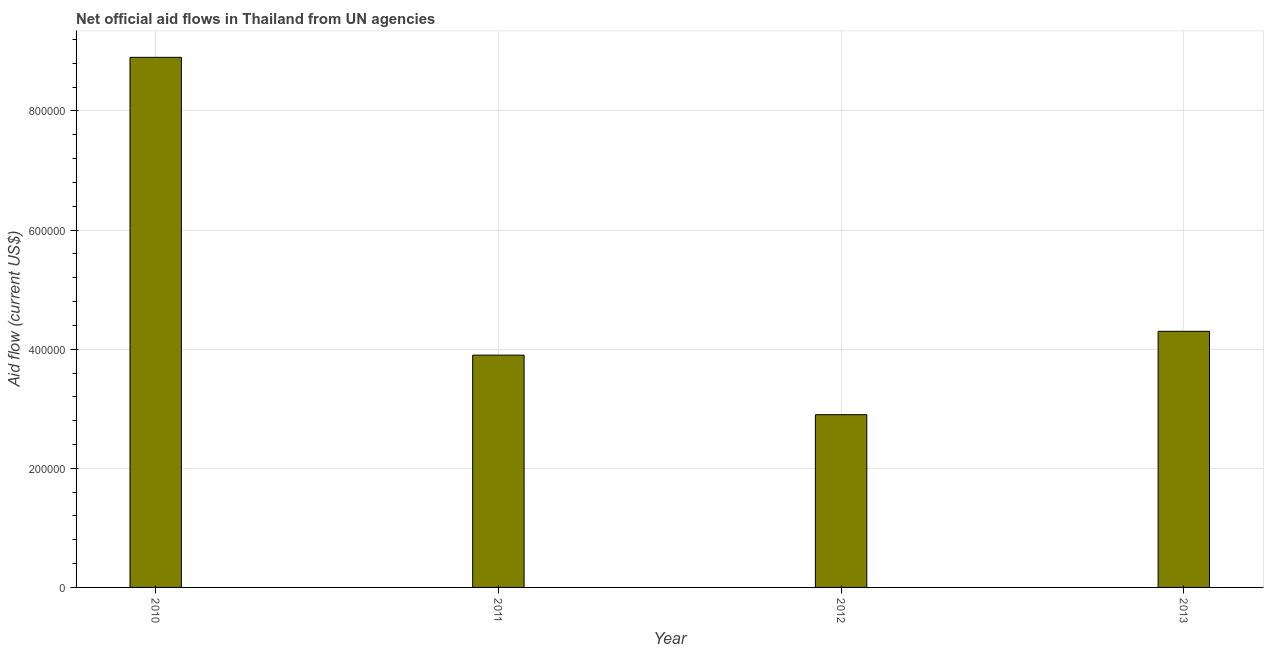Does the graph contain grids?
Make the answer very short. Yes. What is the title of the graph?
Give a very brief answer. Net official aid flows in Thailand from UN agencies. What is the label or title of the X-axis?
Your response must be concise. Year. What is the net official flows from un agencies in 2011?
Offer a very short reply. 3.90e+05. Across all years, what is the maximum net official flows from un agencies?
Provide a short and direct response. 8.90e+05. In how many years, is the net official flows from un agencies greater than 640000 US$?
Give a very brief answer. 1. Do a majority of the years between 2011 and 2010 (inclusive) have net official flows from un agencies greater than 80000 US$?
Offer a terse response. No. What is the ratio of the net official flows from un agencies in 2011 to that in 2012?
Your response must be concise. 1.34. Is the difference between the net official flows from un agencies in 2010 and 2012 greater than the difference between any two years?
Give a very brief answer. Yes. Is the sum of the net official flows from un agencies in 2010 and 2011 greater than the maximum net official flows from un agencies across all years?
Make the answer very short. Yes. How many bars are there?
Provide a short and direct response. 4. How many years are there in the graph?
Provide a succinct answer. 4. What is the difference between two consecutive major ticks on the Y-axis?
Your answer should be compact. 2.00e+05. What is the Aid flow (current US$) of 2010?
Provide a short and direct response. 8.90e+05. What is the Aid flow (current US$) in 2011?
Offer a terse response. 3.90e+05. What is the Aid flow (current US$) in 2012?
Provide a short and direct response. 2.90e+05. What is the difference between the Aid flow (current US$) in 2010 and 2011?
Your answer should be very brief. 5.00e+05. What is the difference between the Aid flow (current US$) in 2010 and 2013?
Make the answer very short. 4.60e+05. What is the difference between the Aid flow (current US$) in 2011 and 2013?
Offer a very short reply. -4.00e+04. What is the ratio of the Aid flow (current US$) in 2010 to that in 2011?
Keep it short and to the point. 2.28. What is the ratio of the Aid flow (current US$) in 2010 to that in 2012?
Offer a terse response. 3.07. What is the ratio of the Aid flow (current US$) in 2010 to that in 2013?
Make the answer very short. 2.07. What is the ratio of the Aid flow (current US$) in 2011 to that in 2012?
Make the answer very short. 1.34. What is the ratio of the Aid flow (current US$) in 2011 to that in 2013?
Your response must be concise. 0.91. What is the ratio of the Aid flow (current US$) in 2012 to that in 2013?
Your answer should be very brief. 0.67. 